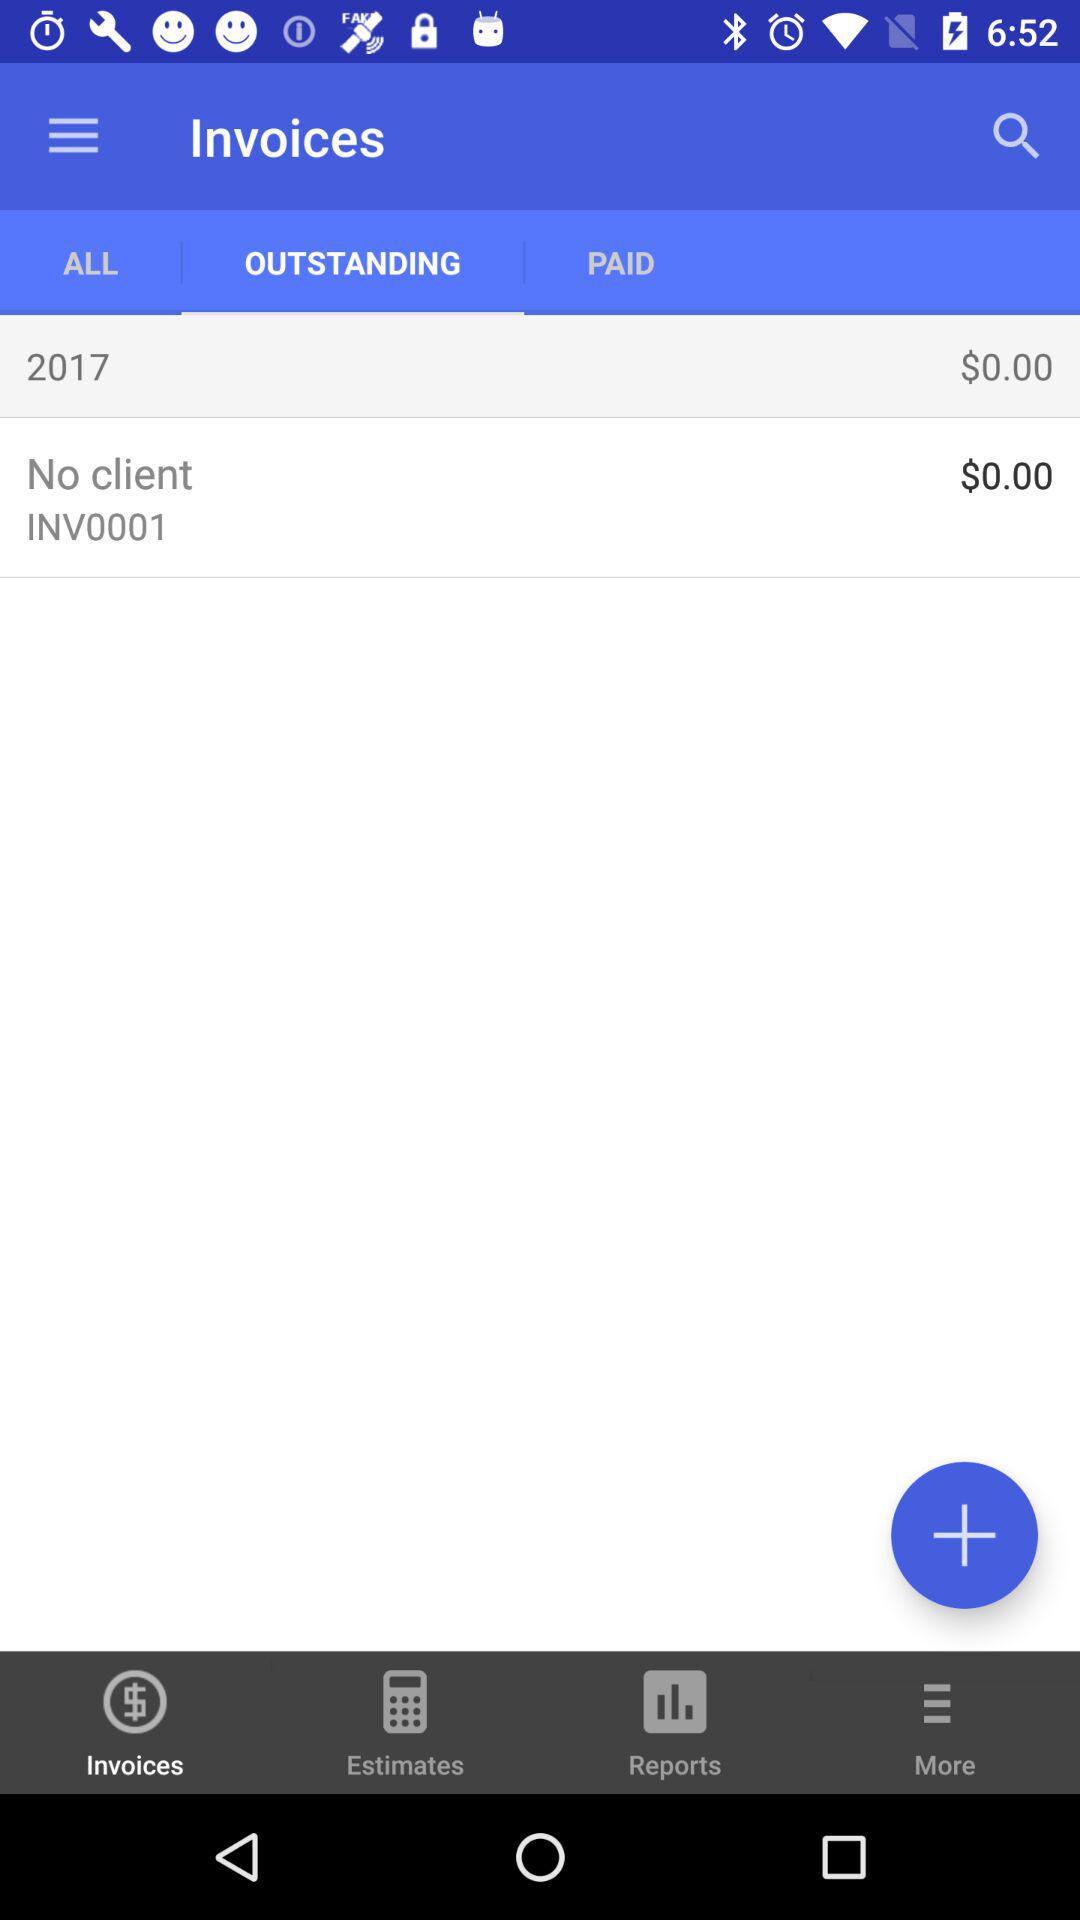Which invoices have been paid?
When the provided information is insufficient, respond with <no answer>. <no answer> 